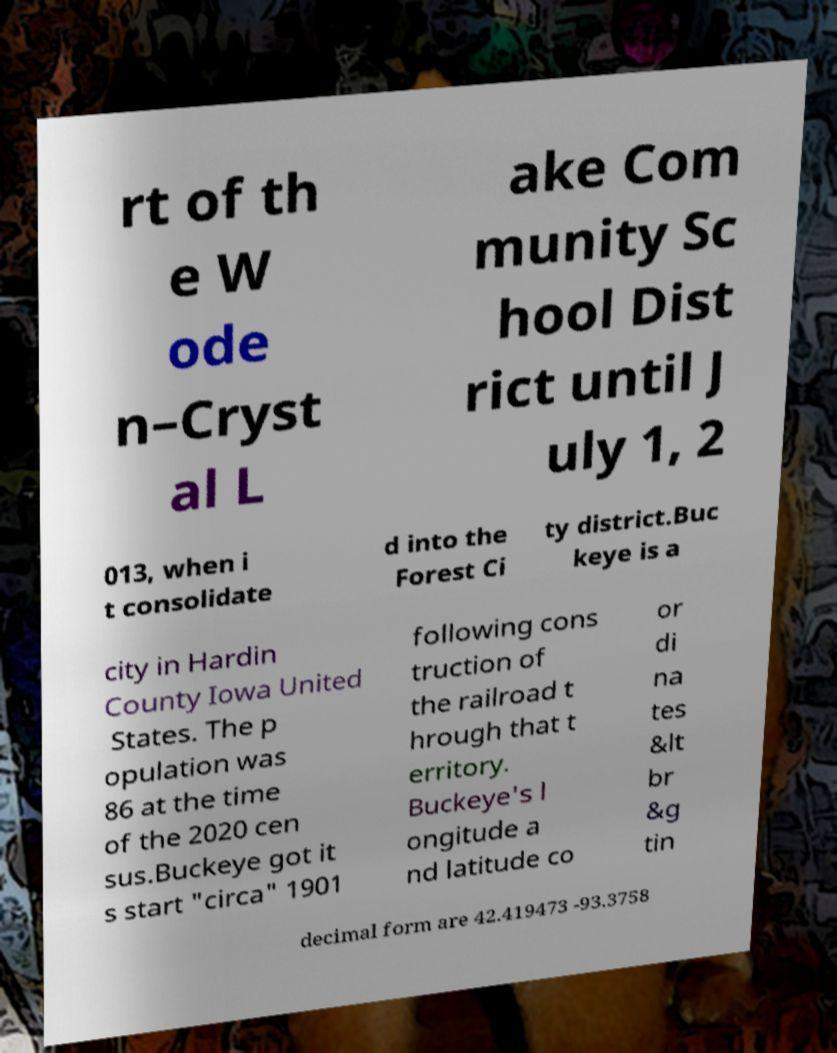Could you assist in decoding the text presented in this image and type it out clearly? rt of th e W ode n–Cryst al L ake Com munity Sc hool Dist rict until J uly 1, 2 013, when i t consolidate d into the Forest Ci ty district.Buc keye is a city in Hardin County Iowa United States. The p opulation was 86 at the time of the 2020 cen sus.Buckeye got it s start "circa" 1901 following cons truction of the railroad t hrough that t erritory. Buckeye's l ongitude a nd latitude co or di na tes &lt br &g tin decimal form are 42.419473 -93.3758 